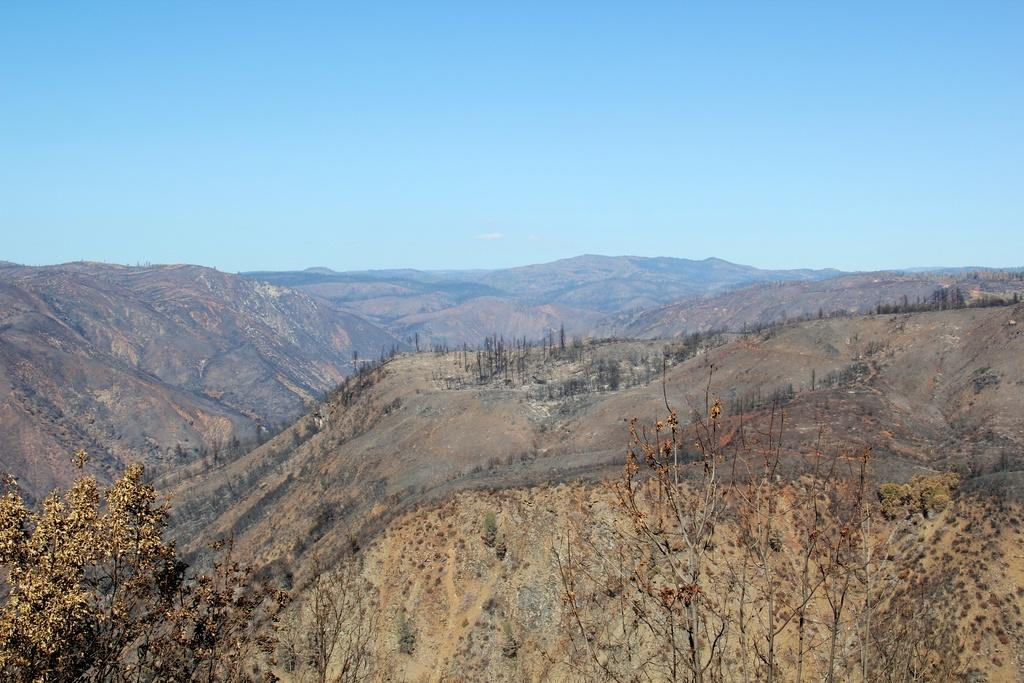What type of natural features can be seen in the image? There are trees and mountains in the image. What is visible in the background of the image? The sky is visible in the background of the image. What can be observed in the sky? Clouds are present in the sky. How many ants can be seen crawling on the trees in the image? There are no ants visible in the image; it features trees and mountains with clouds in the sky. What type of salt is used to season the mountains in the image? There is no salt or seasoning present in the image; it is a natural landscape with trees, mountains, and clouds in the sky. 